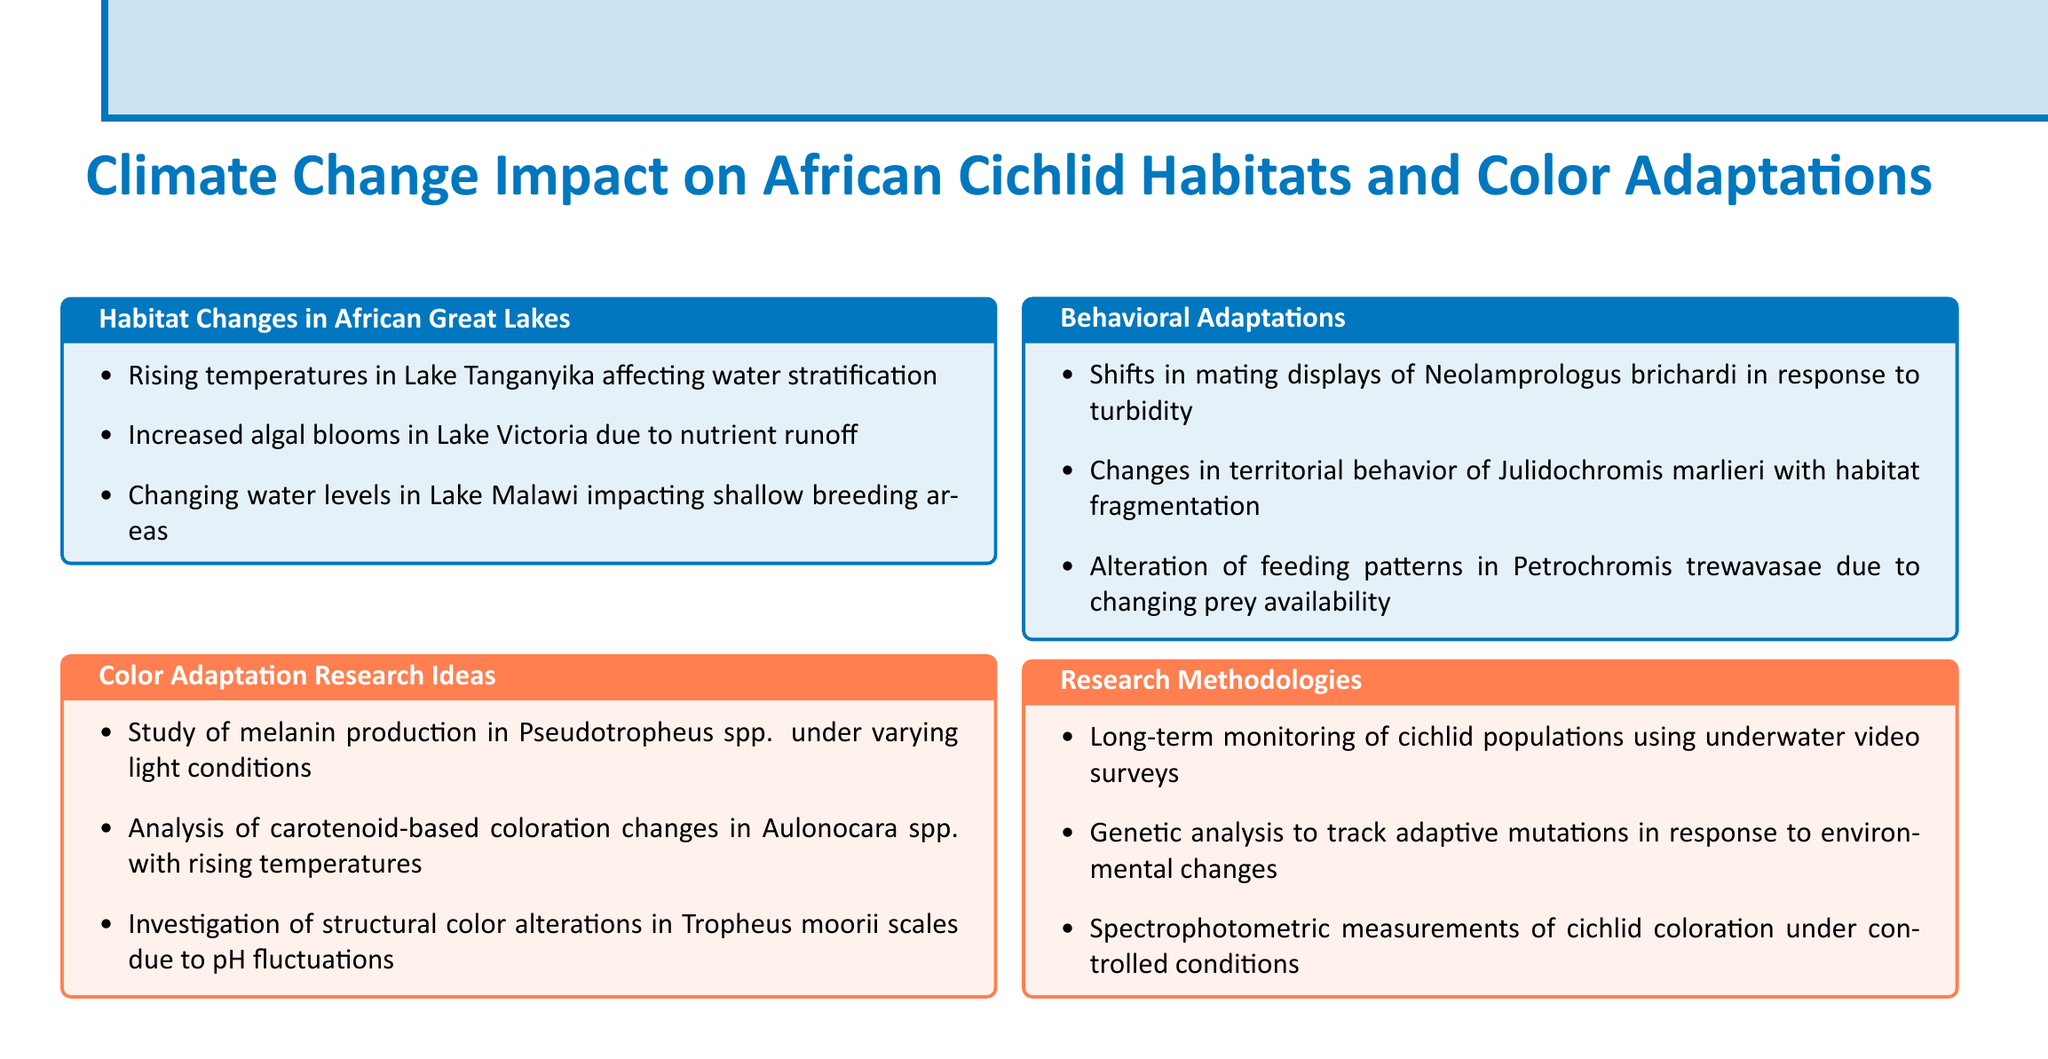What are the rising temperatures affecting? The document cites rising temperatures in Lake Tanganyika affecting water stratification.
Answer: Water stratification What species is studied for melanin production? The document mentions studying melanin production in Pseudotropheus spp. under varying light conditions.
Answer: Pseudotropheus spp What environmental change is linked to increased algal blooms? The document states increased algal blooms in Lake Victoria due to nutrient runoff.
Answer: Nutrient runoff What behavioral change is seen in Neolamprologus brichardi? The document notes shifts in mating displays of Neolamprologus brichardi in response to turbidity.
Answer: Mating displays What research methodology involves underwater video surveys? The document describes long-term monitoring of cichlid populations using underwater video surveys.
Answer: Underwater video surveys Which species undergoes color alterations due to pH fluctuations? The document mentions investigating structural color alterations in Tropheus moorii scales due to pH fluctuations.
Answer: Tropheus moorii What is the focus of genetic analysis in the research methodologies? The document explains that genetic analysis aims to track adaptive mutations in response to environmental changes.
Answer: Adaptive mutations How are feeding patterns of Petrochromis trewavasae affected? The document discusses alteration of feeding patterns in Petrochromis trewavasae due to changing prey availability.
Answer: Changing prey availability 